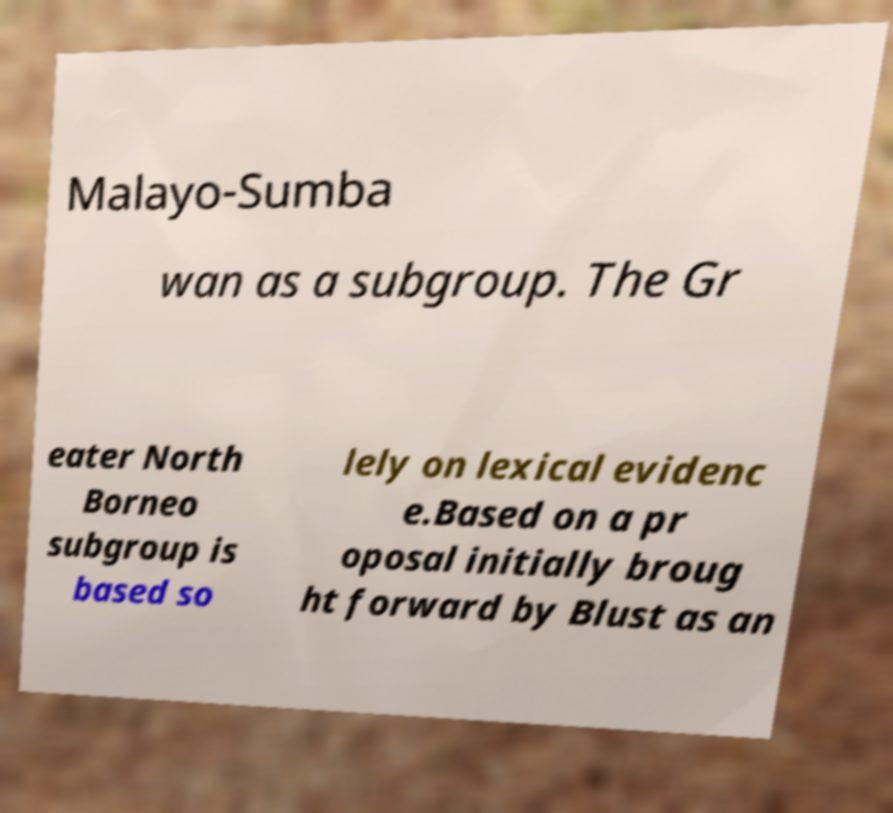Could you assist in decoding the text presented in this image and type it out clearly? Malayo-Sumba wan as a subgroup. The Gr eater North Borneo subgroup is based so lely on lexical evidenc e.Based on a pr oposal initially broug ht forward by Blust as an 